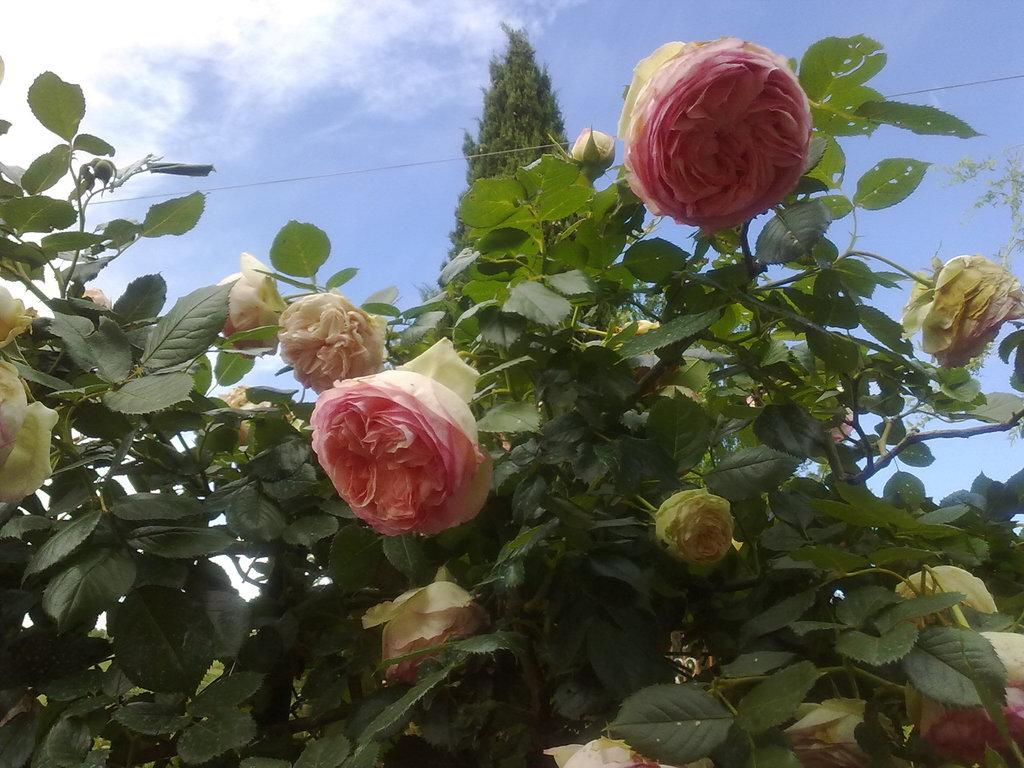What is the main subject in the center of the image? There is a flower of a plant in the center of the image. What can be seen in the background of the image? There is sky visible in the background of the image, along with a tree and clouds. What type of hair can be seen on the flower in the image? There is no hair present on the flower in the image, as flowers do not have hair. 